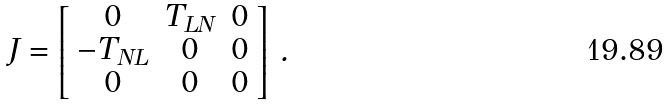Convert formula to latex. <formula><loc_0><loc_0><loc_500><loc_500>J = \left [ \begin{array} { c c c } 0 & T _ { L N } & 0 \\ - T _ { N L } & 0 & 0 \\ 0 & 0 & 0 \end{array} \right ] \, .</formula> 